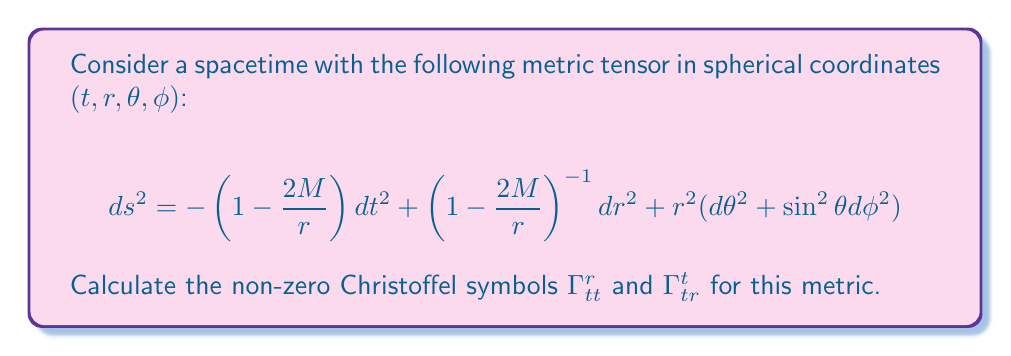Teach me how to tackle this problem. To find the Christoffel symbols, we'll use the formula:

$$\Gamma^\mu_{\alpha\beta} = \frac{1}{2}g^{\mu\nu}\left(\frac{\partial g_{\nu\alpha}}{\partial x^\beta} + \frac{\partial g_{\nu\beta}}{\partial x^\alpha} - \frac{\partial g_{\alpha\beta}}{\partial x^\nu}\right)$$

Step 1: Identify the metric components
$g_{tt} = -\left(1-\frac{2M}{r}\right)$
$g_{rr} = \left(1-\frac{2M}{r}\right)^{-1}$
$g_{\theta\theta} = r^2$
$g_{\phi\phi} = r^2\sin^2\theta$

Step 2: Calculate the inverse metric components
$g^{tt} = -\left(1-\frac{2M}{r}\right)^{-1}$
$g^{rr} = 1-\frac{2M}{r}$

Step 3: Calculate $\Gamma^r_{tt}$
$$\begin{align}
\Gamma^r_{tt} &= \frac{1}{2}g^{rr}\left(\frac{\partial g_{rt}}{\partial t} + \frac{\partial g_{rt}}{\partial t} - \frac{\partial g_{tt}}{\partial r}\right) \\
&= \frac{1}{2}\left(1-\frac{2M}{r}\right)\left(0 + 0 - \frac{\partial}{\partial r}\left(-1+\frac{2M}{r}\right)\right) \\
&= \frac{1}{2}\left(1-\frac{2M}{r}\right)\left(\frac{2M}{r^2}\right) \\
&= \frac{M}{r^2}\left(1-\frac{2M}{r}\right)
\end{align}$$

Step 4: Calculate $\Gamma^t_{tr}$
$$\begin{align}
\Gamma^t_{tr} &= \frac{1}{2}g^{tt}\left(\frac{\partial g_{tt}}{\partial r} + \frac{\partial g_{tr}}{\partial t} - \frac{\partial g_{tr}}{\partial t}\right) \\
&= \frac{1}{2}\left(-1+\frac{2M}{r}\right)^{-1}\left(\frac{\partial}{\partial r}\left(-1+\frac{2M}{r}\right) + 0 - 0\right) \\
&= \frac{1}{2}\left(-1+\frac{2M}{r}\right)^{-1}\left(-\frac{2M}{r^2}\right) \\
&= \frac{M}{r^2}\left(1-\frac{2M}{r}\right)^{-1}
\end{align}$$
Answer: $\Gamma^r_{tt} = \frac{M}{r^2}\left(1-\frac{2M}{r}\right)$, $\Gamma^t_{tr} = \frac{M}{r^2}\left(1-\frac{2M}{r}\right)^{-1}$ 